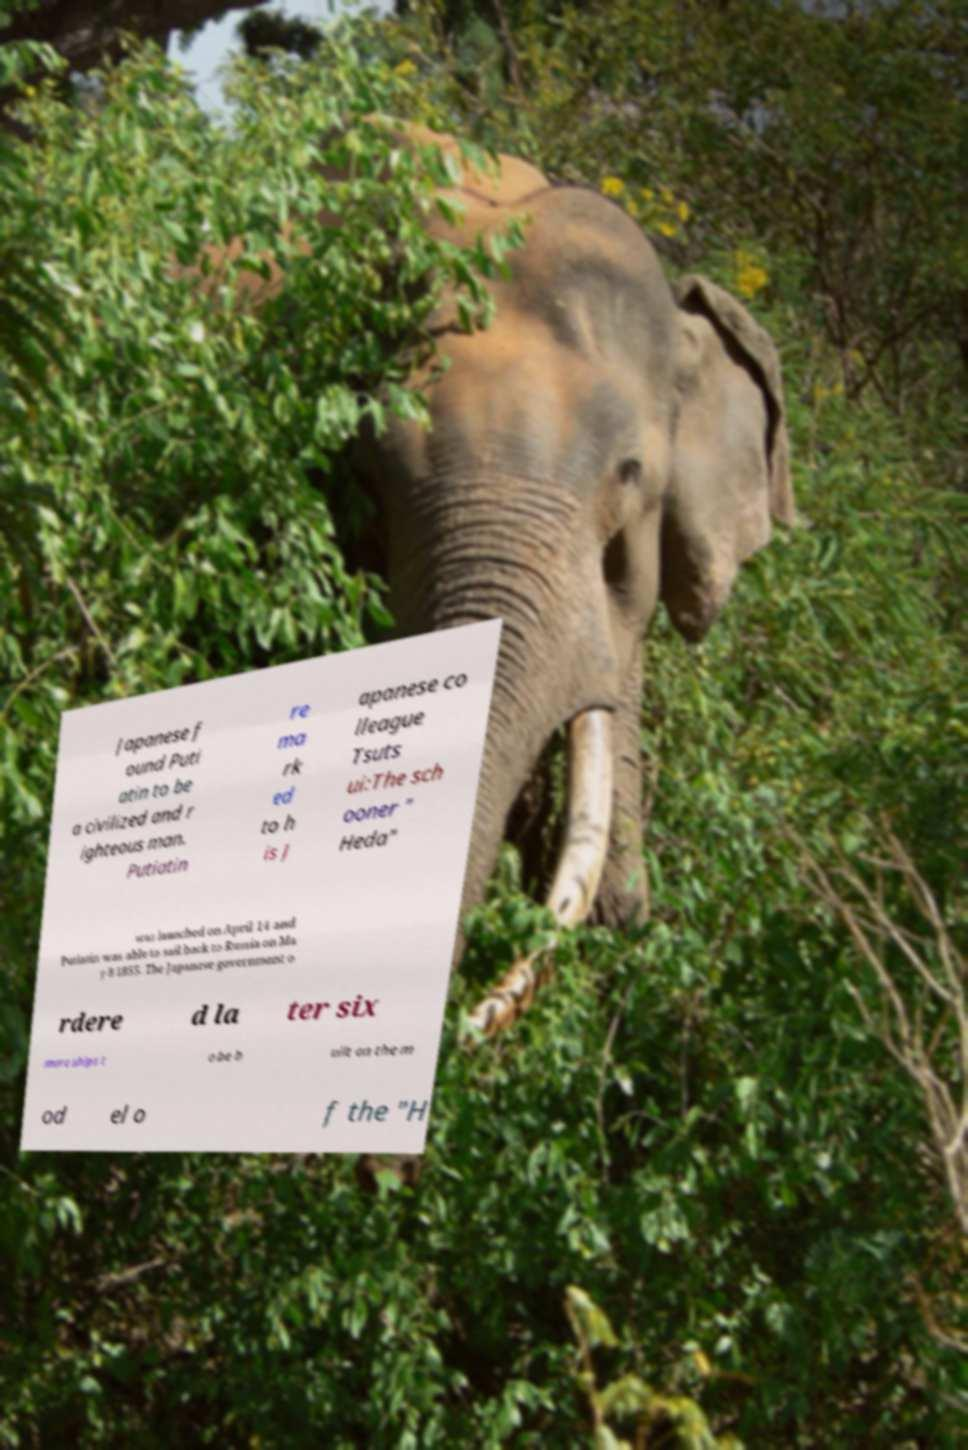Could you assist in decoding the text presented in this image and type it out clearly? Japanese f ound Puti atin to be a civilized and r ighteous man. Putiatin re ma rk ed to h is J apanese co lleague Tsuts ui:The sch ooner " Heda" was launched on April 14 and Putiatin was able to sail back to Russia on Ma y 8 1855. The Japanese government o rdere d la ter six more ships t o be b uilt on the m od el o f the "H 